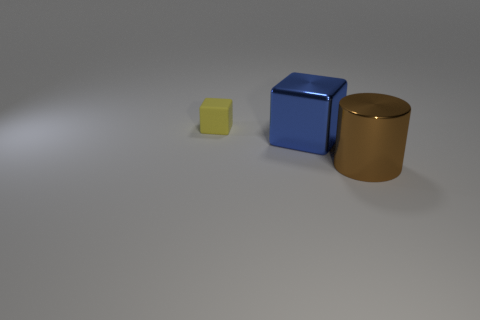There is a block to the right of the yellow object; is it the same size as the object that is behind the big blue shiny object?
Give a very brief answer. No. What size is the blue thing that is the same material as the large brown thing?
Keep it short and to the point. Large. Are there any metal objects of the same color as the large cylinder?
Ensure brevity in your answer.  No. Does the brown cylinder have the same size as the metallic thing that is to the left of the large brown cylinder?
Provide a succinct answer. Yes. What number of small objects are in front of the big thing that is right of the block that is on the right side of the small yellow matte object?
Make the answer very short. 0. There is a large brown shiny thing; are there any brown shiny cylinders left of it?
Provide a succinct answer. No. What is the shape of the matte object?
Keep it short and to the point. Cube. What shape is the large object behind the big metal thing in front of the cube in front of the small matte thing?
Your answer should be very brief. Cube. What number of other things are there of the same shape as the small yellow matte thing?
Your answer should be very brief. 1. There is a big thing that is on the right side of the block right of the yellow thing; what is its material?
Make the answer very short. Metal. 